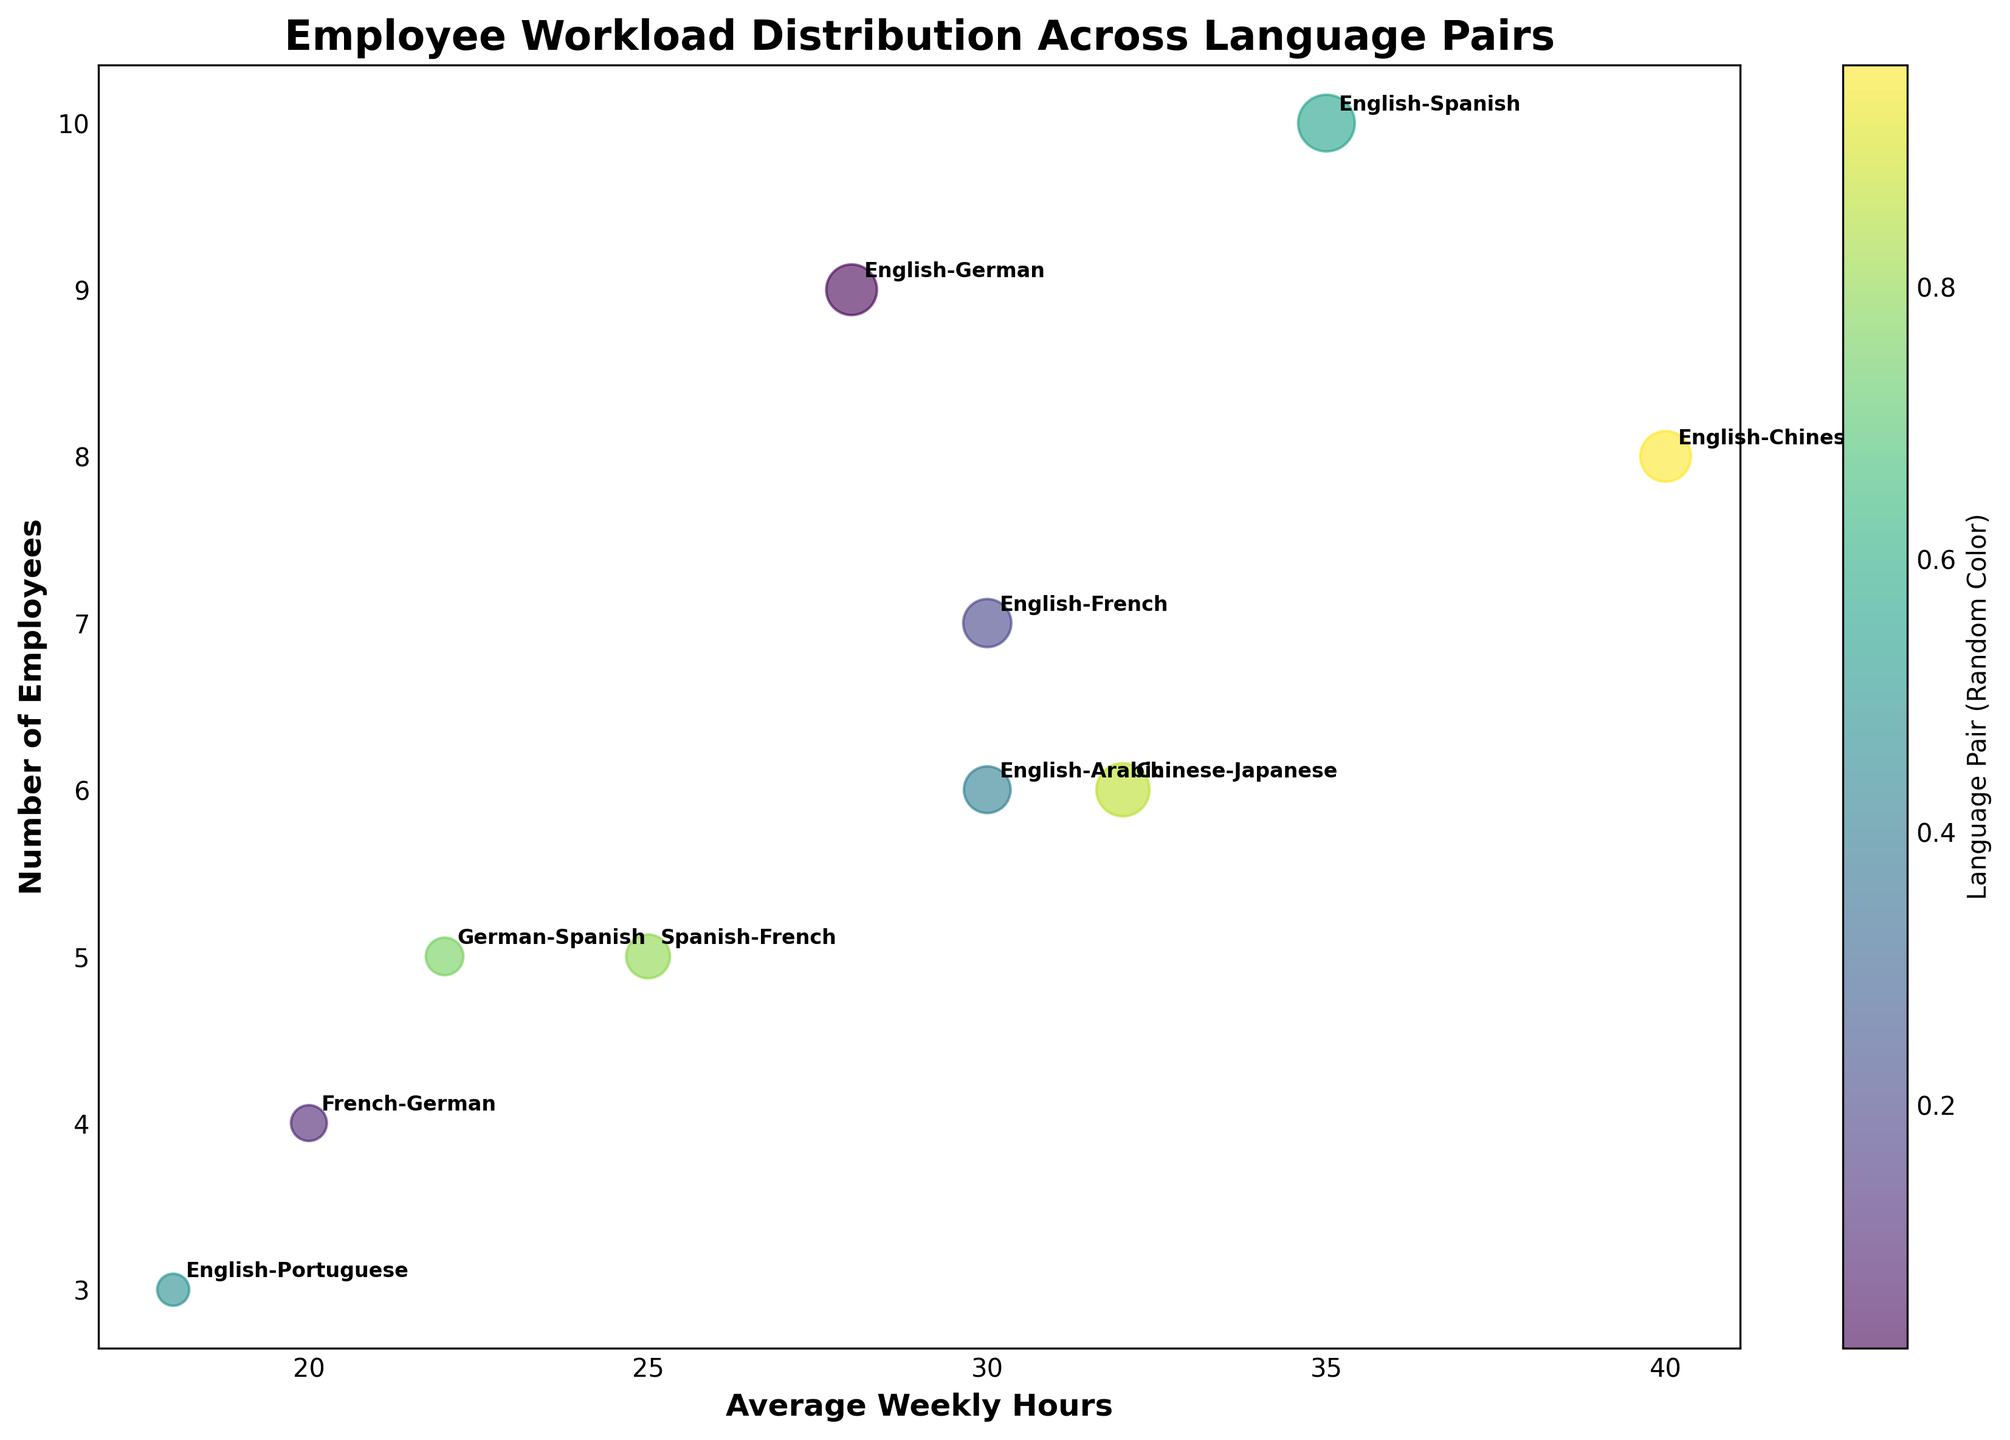What is the title of the figure? The title is usually displayed prominently at the top of the chart. In this case, it reads "Employee Workload Distribution Across Language Pairs."
Answer: Employee Workload Distribution Across Language Pairs Which language pair has the highest number of employees? By looking at the y-axis, which represents the number of employees, we see that the English-Spanish bubble is highest, indicating it has the most employees.
Answer: English-Spanish What is the average weekly hours for the English-German language pair? Locate the English-German bubble and refer to its position on the x-axis to find the average weekly hours. It's at 28 hours.
Answer: 28 What does the size of each bubble represent? The size of the bubbles, which varies, reflects the number of projects for each language pair. Larger bubbles mean more projects.
Answer: Number of projects How many language pairs have an average weekly hours exceeding 30? Identify all bubbles placed to the right of the 30-hour mark on the x-axis. The language pairs are English-Chinese, Chinese-Japanese, and English-Arabic, totaling 3.
Answer: 3 Which language pair has the smallest number of projects? The smallest bubbles indicate the least projects. The English-Portuguese bubble is the smallest, representing 8 projects.
Answer: English-Portuguese What language pair works the least average weekly hours and how many hours do they work on average? Find the bubble closest to the left on the x-axis, which represents the minimum weekly hours. The English-Portuguese pair works 18 hours on average.
Answer: English-Portuguese, 18 hours Compare the number of employees and the average weekly hours of English-Chinese and English-French. Which pair has more employees and more average weekly hours? The English-Chinese bubble is positioned higher on the y-axis and further right on the x-axis, indicating more employees and higher average weekly hours than the English-French bubble.
Answer: English-Chinese Which language pair has a high number of employees but relatively few projects? Identify a high bubble (many employees) with a relatively small size (few projects). English-Spanish bubble is high on the y-axis but not the largest, indicating many employees (10) with a moderate number of projects (25).
Answer: English-Spanish What color range represents the bubbles, and what does it signify? The bubbles display a range of colors indicated by the colorbar on the right. Because colors are randomly assigned, they do not signify any specific metric.
Answer: Random colors, no specific metric 